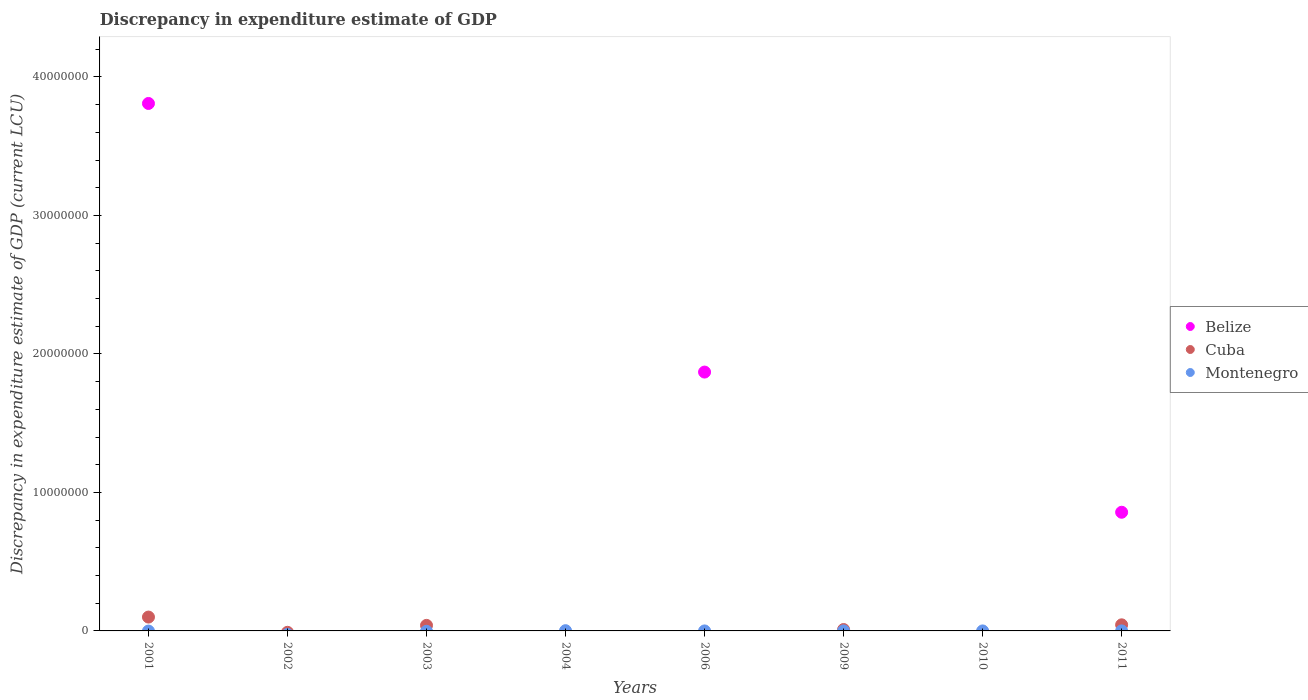Is the number of dotlines equal to the number of legend labels?
Offer a terse response. No. Across all years, what is the maximum discrepancy in expenditure estimate of GDP in Belize?
Make the answer very short. 3.81e+07. Across all years, what is the minimum discrepancy in expenditure estimate of GDP in Cuba?
Your answer should be very brief. 0. What is the total discrepancy in expenditure estimate of GDP in Belize in the graph?
Make the answer very short. 6.53e+07. What is the difference between the discrepancy in expenditure estimate of GDP in Belize in 2001 and that in 2006?
Offer a terse response. 1.94e+07. What is the difference between the discrepancy in expenditure estimate of GDP in Belize in 2003 and the discrepancy in expenditure estimate of GDP in Montenegro in 2009?
Ensure brevity in your answer.  -6.2e-7. What is the average discrepancy in expenditure estimate of GDP in Montenegro per year?
Provide a short and direct response. 2125. In the year 2001, what is the difference between the discrepancy in expenditure estimate of GDP in Belize and discrepancy in expenditure estimate of GDP in Cuba?
Offer a terse response. 3.71e+07. In how many years, is the discrepancy in expenditure estimate of GDP in Montenegro greater than 40000000 LCU?
Ensure brevity in your answer.  0. What is the difference between the highest and the second highest discrepancy in expenditure estimate of GDP in Cuba?
Keep it short and to the point. 5.60e+05. What is the difference between the highest and the lowest discrepancy in expenditure estimate of GDP in Belize?
Your answer should be very brief. 3.81e+07. In how many years, is the discrepancy in expenditure estimate of GDP in Belize greater than the average discrepancy in expenditure estimate of GDP in Belize taken over all years?
Offer a very short reply. 3. Is it the case that in every year, the sum of the discrepancy in expenditure estimate of GDP in Cuba and discrepancy in expenditure estimate of GDP in Belize  is greater than the discrepancy in expenditure estimate of GDP in Montenegro?
Make the answer very short. No. Is the discrepancy in expenditure estimate of GDP in Montenegro strictly greater than the discrepancy in expenditure estimate of GDP in Cuba over the years?
Provide a succinct answer. No. Is the discrepancy in expenditure estimate of GDP in Montenegro strictly less than the discrepancy in expenditure estimate of GDP in Belize over the years?
Offer a very short reply. No. Does the graph contain any zero values?
Offer a terse response. Yes. How are the legend labels stacked?
Make the answer very short. Vertical. What is the title of the graph?
Your response must be concise. Discrepancy in expenditure estimate of GDP. Does "Sub-Saharan Africa (all income levels)" appear as one of the legend labels in the graph?
Your answer should be compact. No. What is the label or title of the Y-axis?
Make the answer very short. Discrepancy in expenditure estimate of GDP (current LCU). What is the Discrepancy in expenditure estimate of GDP (current LCU) in Belize in 2001?
Ensure brevity in your answer.  3.81e+07. What is the Discrepancy in expenditure estimate of GDP (current LCU) in Cuba in 2002?
Make the answer very short. 0. What is the Discrepancy in expenditure estimate of GDP (current LCU) of Montenegro in 2002?
Provide a succinct answer. 0. What is the Discrepancy in expenditure estimate of GDP (current LCU) in Cuba in 2003?
Provide a short and direct response. 4.00e+05. What is the Discrepancy in expenditure estimate of GDP (current LCU) in Montenegro in 2003?
Offer a terse response. 0. What is the Discrepancy in expenditure estimate of GDP (current LCU) of Belize in 2004?
Your answer should be compact. 0. What is the Discrepancy in expenditure estimate of GDP (current LCU) of Montenegro in 2004?
Offer a very short reply. 1.70e+04. What is the Discrepancy in expenditure estimate of GDP (current LCU) of Belize in 2006?
Provide a short and direct response. 1.87e+07. What is the Discrepancy in expenditure estimate of GDP (current LCU) in Cuba in 2006?
Make the answer very short. 0. What is the Discrepancy in expenditure estimate of GDP (current LCU) of Montenegro in 2006?
Your response must be concise. 0. What is the Discrepancy in expenditure estimate of GDP (current LCU) in Belize in 2009?
Ensure brevity in your answer.  0. What is the Discrepancy in expenditure estimate of GDP (current LCU) of Montenegro in 2009?
Offer a very short reply. 6.2e-7. What is the Discrepancy in expenditure estimate of GDP (current LCU) of Belize in 2010?
Your response must be concise. 0. What is the Discrepancy in expenditure estimate of GDP (current LCU) in Cuba in 2010?
Offer a very short reply. 0. What is the Discrepancy in expenditure estimate of GDP (current LCU) in Montenegro in 2010?
Provide a short and direct response. 0. What is the Discrepancy in expenditure estimate of GDP (current LCU) of Belize in 2011?
Your answer should be compact. 8.57e+06. What is the Discrepancy in expenditure estimate of GDP (current LCU) of Cuba in 2011?
Your answer should be very brief. 4.40e+05. What is the Discrepancy in expenditure estimate of GDP (current LCU) of Montenegro in 2011?
Offer a very short reply. 3.8e-7. Across all years, what is the maximum Discrepancy in expenditure estimate of GDP (current LCU) in Belize?
Provide a short and direct response. 3.81e+07. Across all years, what is the maximum Discrepancy in expenditure estimate of GDP (current LCU) in Montenegro?
Your answer should be very brief. 1.70e+04. Across all years, what is the minimum Discrepancy in expenditure estimate of GDP (current LCU) of Montenegro?
Offer a very short reply. 0. What is the total Discrepancy in expenditure estimate of GDP (current LCU) of Belize in the graph?
Your answer should be very brief. 6.53e+07. What is the total Discrepancy in expenditure estimate of GDP (current LCU) in Cuba in the graph?
Your response must be concise. 1.94e+06. What is the total Discrepancy in expenditure estimate of GDP (current LCU) in Montenegro in the graph?
Ensure brevity in your answer.  1.70e+04. What is the difference between the Discrepancy in expenditure estimate of GDP (current LCU) of Belize in 2001 and that in 2006?
Offer a terse response. 1.94e+07. What is the difference between the Discrepancy in expenditure estimate of GDP (current LCU) of Cuba in 2001 and that in 2009?
Make the answer very short. 9.00e+05. What is the difference between the Discrepancy in expenditure estimate of GDP (current LCU) of Belize in 2001 and that in 2011?
Make the answer very short. 2.95e+07. What is the difference between the Discrepancy in expenditure estimate of GDP (current LCU) of Cuba in 2001 and that in 2011?
Make the answer very short. 5.60e+05. What is the difference between the Discrepancy in expenditure estimate of GDP (current LCU) of Cuba in 2003 and that in 2009?
Make the answer very short. 3.00e+05. What is the difference between the Discrepancy in expenditure estimate of GDP (current LCU) of Cuba in 2003 and that in 2011?
Make the answer very short. -4.00e+04. What is the difference between the Discrepancy in expenditure estimate of GDP (current LCU) of Montenegro in 2004 and that in 2009?
Offer a terse response. 1.70e+04. What is the difference between the Discrepancy in expenditure estimate of GDP (current LCU) in Montenegro in 2004 and that in 2011?
Offer a terse response. 1.70e+04. What is the difference between the Discrepancy in expenditure estimate of GDP (current LCU) of Belize in 2006 and that in 2011?
Offer a very short reply. 1.01e+07. What is the difference between the Discrepancy in expenditure estimate of GDP (current LCU) in Montenegro in 2009 and that in 2011?
Offer a very short reply. 0. What is the difference between the Discrepancy in expenditure estimate of GDP (current LCU) of Belize in 2001 and the Discrepancy in expenditure estimate of GDP (current LCU) of Cuba in 2003?
Provide a short and direct response. 3.77e+07. What is the difference between the Discrepancy in expenditure estimate of GDP (current LCU) of Belize in 2001 and the Discrepancy in expenditure estimate of GDP (current LCU) of Montenegro in 2004?
Your answer should be very brief. 3.81e+07. What is the difference between the Discrepancy in expenditure estimate of GDP (current LCU) of Cuba in 2001 and the Discrepancy in expenditure estimate of GDP (current LCU) of Montenegro in 2004?
Your response must be concise. 9.83e+05. What is the difference between the Discrepancy in expenditure estimate of GDP (current LCU) in Belize in 2001 and the Discrepancy in expenditure estimate of GDP (current LCU) in Cuba in 2009?
Make the answer very short. 3.80e+07. What is the difference between the Discrepancy in expenditure estimate of GDP (current LCU) of Belize in 2001 and the Discrepancy in expenditure estimate of GDP (current LCU) of Montenegro in 2009?
Your response must be concise. 3.81e+07. What is the difference between the Discrepancy in expenditure estimate of GDP (current LCU) of Belize in 2001 and the Discrepancy in expenditure estimate of GDP (current LCU) of Cuba in 2011?
Offer a terse response. 3.76e+07. What is the difference between the Discrepancy in expenditure estimate of GDP (current LCU) of Belize in 2001 and the Discrepancy in expenditure estimate of GDP (current LCU) of Montenegro in 2011?
Ensure brevity in your answer.  3.81e+07. What is the difference between the Discrepancy in expenditure estimate of GDP (current LCU) of Cuba in 2003 and the Discrepancy in expenditure estimate of GDP (current LCU) of Montenegro in 2004?
Your response must be concise. 3.83e+05. What is the difference between the Discrepancy in expenditure estimate of GDP (current LCU) in Cuba in 2003 and the Discrepancy in expenditure estimate of GDP (current LCU) in Montenegro in 2009?
Provide a succinct answer. 4.00e+05. What is the difference between the Discrepancy in expenditure estimate of GDP (current LCU) of Belize in 2006 and the Discrepancy in expenditure estimate of GDP (current LCU) of Cuba in 2009?
Provide a succinct answer. 1.86e+07. What is the difference between the Discrepancy in expenditure estimate of GDP (current LCU) of Belize in 2006 and the Discrepancy in expenditure estimate of GDP (current LCU) of Montenegro in 2009?
Give a very brief answer. 1.87e+07. What is the difference between the Discrepancy in expenditure estimate of GDP (current LCU) in Belize in 2006 and the Discrepancy in expenditure estimate of GDP (current LCU) in Cuba in 2011?
Provide a short and direct response. 1.82e+07. What is the difference between the Discrepancy in expenditure estimate of GDP (current LCU) of Belize in 2006 and the Discrepancy in expenditure estimate of GDP (current LCU) of Montenegro in 2011?
Your response must be concise. 1.87e+07. What is the average Discrepancy in expenditure estimate of GDP (current LCU) of Belize per year?
Keep it short and to the point. 8.17e+06. What is the average Discrepancy in expenditure estimate of GDP (current LCU) in Cuba per year?
Keep it short and to the point. 2.42e+05. What is the average Discrepancy in expenditure estimate of GDP (current LCU) of Montenegro per year?
Keep it short and to the point. 2125. In the year 2001, what is the difference between the Discrepancy in expenditure estimate of GDP (current LCU) of Belize and Discrepancy in expenditure estimate of GDP (current LCU) of Cuba?
Ensure brevity in your answer.  3.71e+07. In the year 2011, what is the difference between the Discrepancy in expenditure estimate of GDP (current LCU) in Belize and Discrepancy in expenditure estimate of GDP (current LCU) in Cuba?
Offer a very short reply. 8.13e+06. In the year 2011, what is the difference between the Discrepancy in expenditure estimate of GDP (current LCU) of Belize and Discrepancy in expenditure estimate of GDP (current LCU) of Montenegro?
Your response must be concise. 8.57e+06. In the year 2011, what is the difference between the Discrepancy in expenditure estimate of GDP (current LCU) of Cuba and Discrepancy in expenditure estimate of GDP (current LCU) of Montenegro?
Ensure brevity in your answer.  4.40e+05. What is the ratio of the Discrepancy in expenditure estimate of GDP (current LCU) of Belize in 2001 to that in 2006?
Give a very brief answer. 2.04. What is the ratio of the Discrepancy in expenditure estimate of GDP (current LCU) in Cuba in 2001 to that in 2009?
Give a very brief answer. 10. What is the ratio of the Discrepancy in expenditure estimate of GDP (current LCU) in Belize in 2001 to that in 2011?
Your answer should be very brief. 4.44. What is the ratio of the Discrepancy in expenditure estimate of GDP (current LCU) in Cuba in 2001 to that in 2011?
Provide a succinct answer. 2.27. What is the ratio of the Discrepancy in expenditure estimate of GDP (current LCU) of Cuba in 2003 to that in 2011?
Offer a very short reply. 0.91. What is the ratio of the Discrepancy in expenditure estimate of GDP (current LCU) in Montenegro in 2004 to that in 2009?
Keep it short and to the point. 2.74e+1. What is the ratio of the Discrepancy in expenditure estimate of GDP (current LCU) in Montenegro in 2004 to that in 2011?
Make the answer very short. 4.47e+1. What is the ratio of the Discrepancy in expenditure estimate of GDP (current LCU) in Belize in 2006 to that in 2011?
Offer a terse response. 2.18. What is the ratio of the Discrepancy in expenditure estimate of GDP (current LCU) in Cuba in 2009 to that in 2011?
Your answer should be compact. 0.23. What is the ratio of the Discrepancy in expenditure estimate of GDP (current LCU) of Montenegro in 2009 to that in 2011?
Make the answer very short. 1.63. What is the difference between the highest and the second highest Discrepancy in expenditure estimate of GDP (current LCU) of Belize?
Your answer should be very brief. 1.94e+07. What is the difference between the highest and the second highest Discrepancy in expenditure estimate of GDP (current LCU) of Cuba?
Keep it short and to the point. 5.60e+05. What is the difference between the highest and the second highest Discrepancy in expenditure estimate of GDP (current LCU) of Montenegro?
Your answer should be very brief. 1.70e+04. What is the difference between the highest and the lowest Discrepancy in expenditure estimate of GDP (current LCU) in Belize?
Provide a short and direct response. 3.81e+07. What is the difference between the highest and the lowest Discrepancy in expenditure estimate of GDP (current LCU) of Cuba?
Offer a very short reply. 1.00e+06. What is the difference between the highest and the lowest Discrepancy in expenditure estimate of GDP (current LCU) of Montenegro?
Your response must be concise. 1.70e+04. 